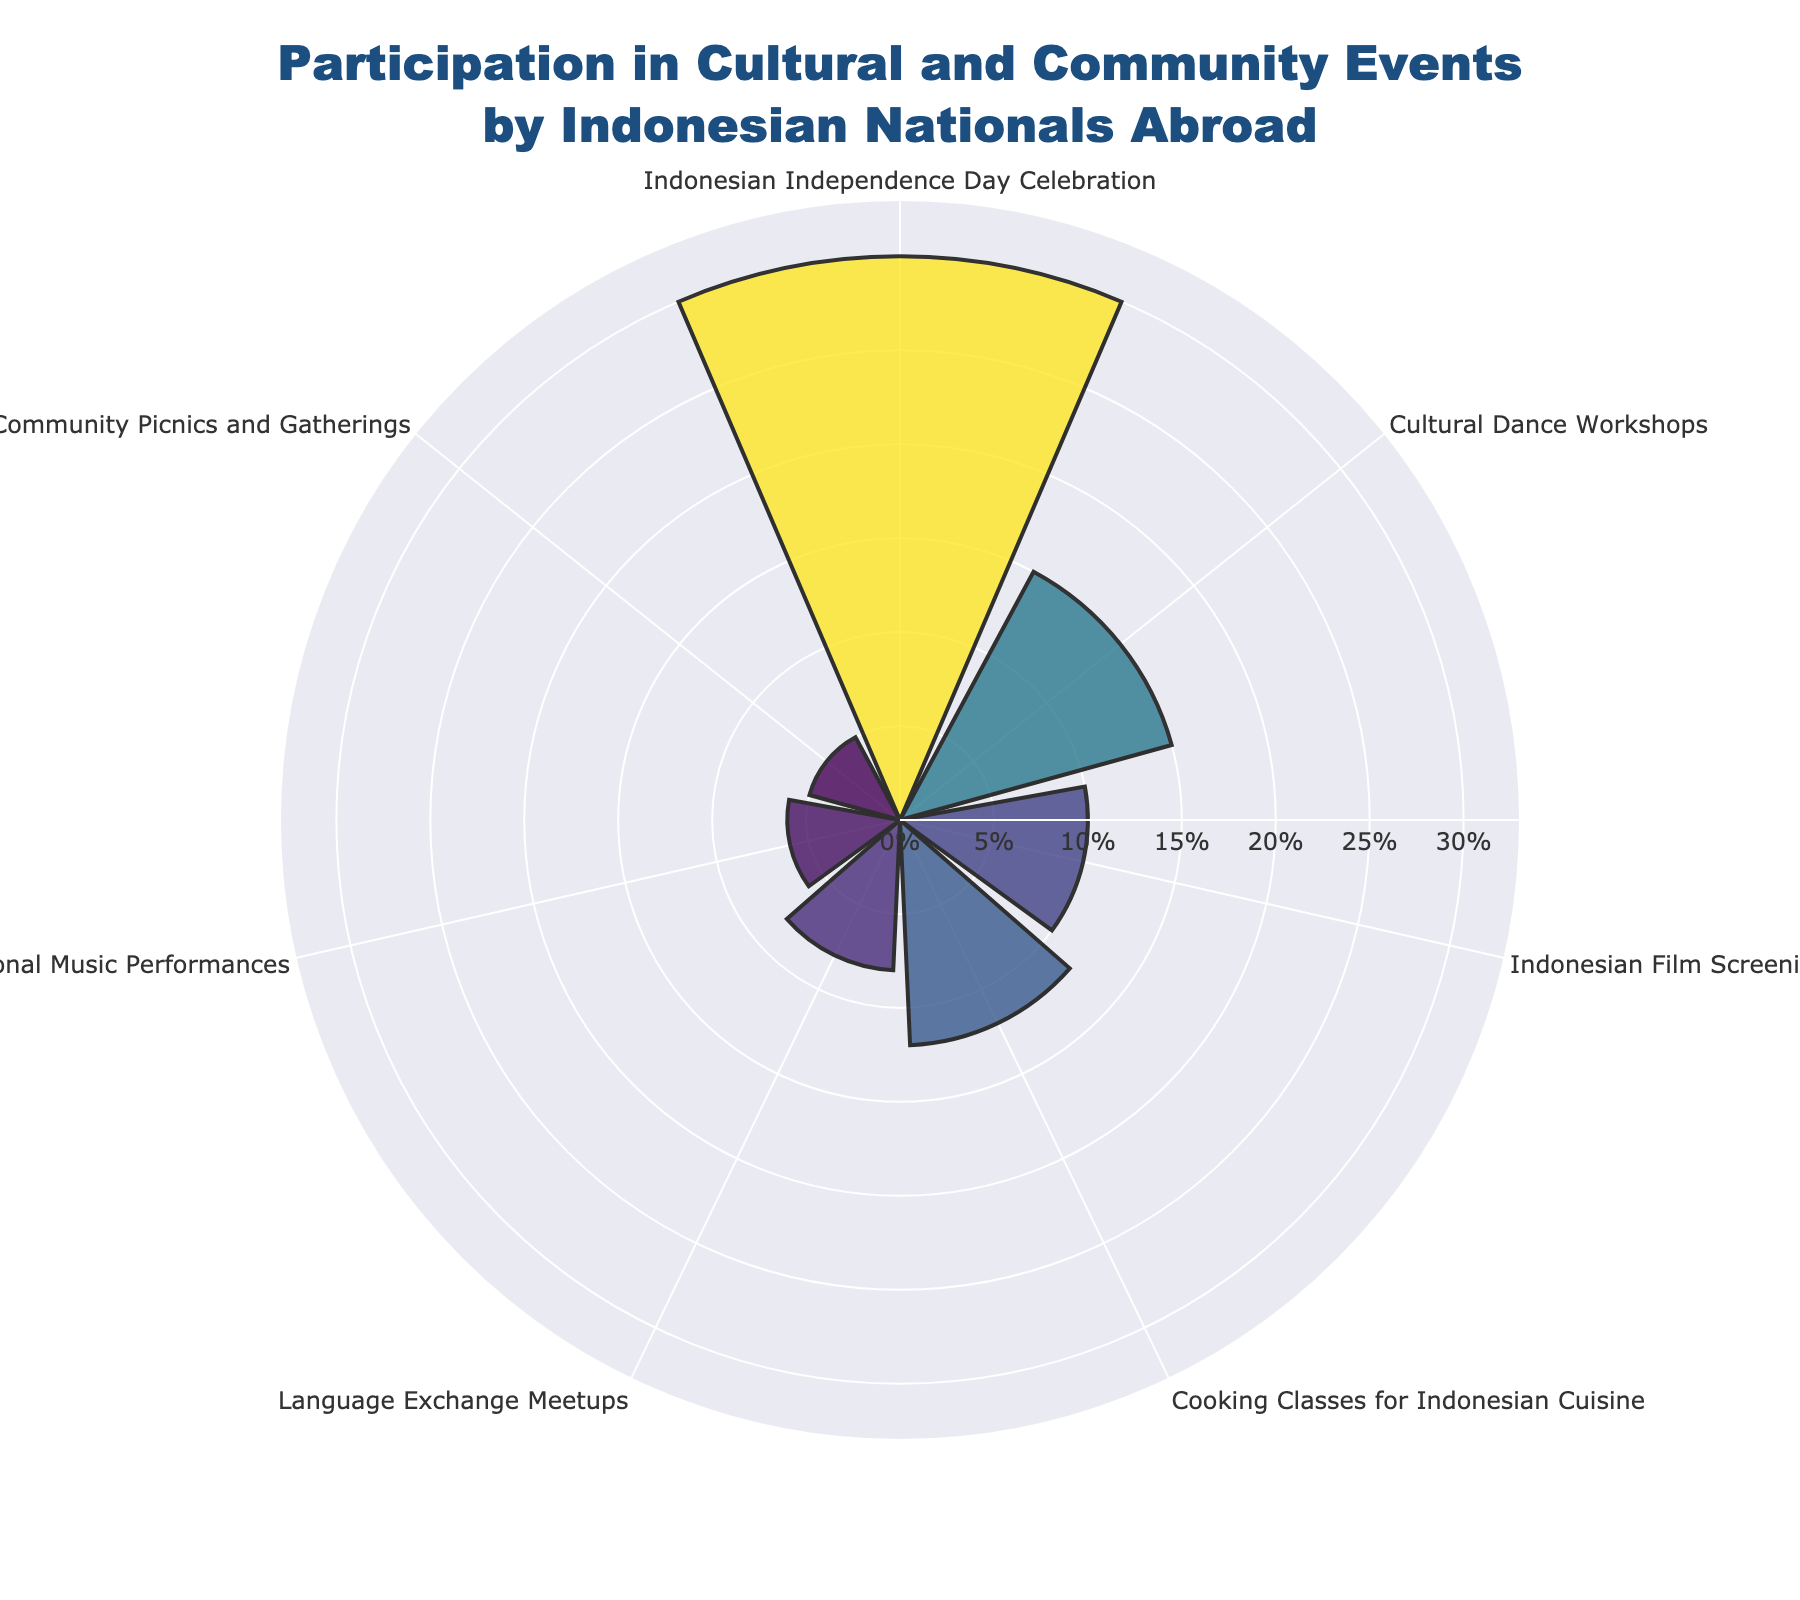What's the title of the figure? The title is usually displayed at the top of the figure in a larger font size and stands out. The title here is "Participation in Cultural and Community Events by Indonesian Nationals Abroad", which provides an overview of the data visualized.
Answer: Participation in Cultural and Community Events by Indonesian Nationals Abroad How many event categories are shown in the figure? To determine the number of event categories, look at the labels along the angular axis of the rose chart. Each label represents a different event category. There are 7 different events in the figure.
Answer: 7 Which event has the highest percentage of participants? The event with the longest bar in the rose chart represents the highest percentage. The label for this longest bar is "Indonesian Independence Day Celebration", which is at 30%.
Answer: Indonesian Independence Day Celebration What is the combined percentage of participants for Indonesian Film Screenings and Cooking Classes for Indonesian Cuisine? Find the percentage for each event and add them up. Indonesian Film Screenings have 10% and Cooking Classes for Indonesian Cuisine have 12%. Combining them gives 10% + 12% = 22%.
Answer: 22% What is the difference in participation percentage between Cultural Dance Workshops and Community Picnics and Gatherings? Identify the percentage for each event and subtract one from the other. Cultural Dance Workshops have 15% and Community Picnics and Gatherings have 5%. The difference is 15% - 5% = 10%.
Answer: 10% Which two events have the smallest percentage of participants? The shortest bars represent the smallest percentages. Traditional Music Performances and Community Picnics and Gatherings are the smallest, with 6% and 5% respectively.
Answer: Traditional Music Performances and Community Picnics and Gatherings What is the average percentage of participants for the events? Sum the percentages of all events and divide by the number of events. Sum = 30% + 15% + 10% + 12% + 8% + 6% + 5% = 86%. Average = 86% / 7 = 12.29%.
Answer: 12.29% How many events have a participation percentage below the average? First, compute the average participation percentage (12.29%). Then count how many events are below this percentage. The events below 12.29% are Indonesian Film Screenings (10%), Language Exchange Meetups (8%), Traditional Music Performances (6%), and Community Picnics and Gatherings (5%). This makes 4 events.
Answer: 4 Is the participation in Cooking Classes for Indonesian Cuisine greater than in Language Exchange Meetups and Traditional Music Performances combined? Compare the percentage of Cooking Classes for Indonesian Cuisine (12%) with the sum of Language Exchange Meetups (8%) and Traditional Music Performances (6%). 12% is less than 8% + 6% = 14%.
Answer: No 